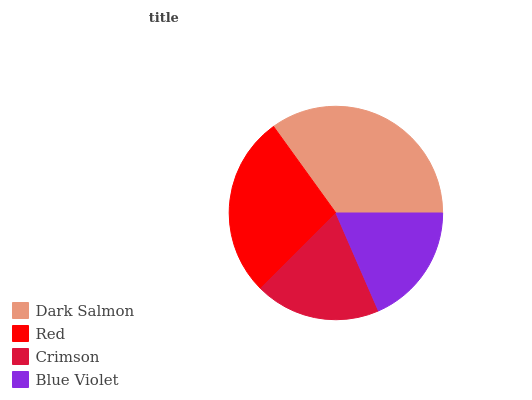Is Blue Violet the minimum?
Answer yes or no. Yes. Is Dark Salmon the maximum?
Answer yes or no. Yes. Is Red the minimum?
Answer yes or no. No. Is Red the maximum?
Answer yes or no. No. Is Dark Salmon greater than Red?
Answer yes or no. Yes. Is Red less than Dark Salmon?
Answer yes or no. Yes. Is Red greater than Dark Salmon?
Answer yes or no. No. Is Dark Salmon less than Red?
Answer yes or no. No. Is Red the high median?
Answer yes or no. Yes. Is Crimson the low median?
Answer yes or no. Yes. Is Dark Salmon the high median?
Answer yes or no. No. Is Blue Violet the low median?
Answer yes or no. No. 